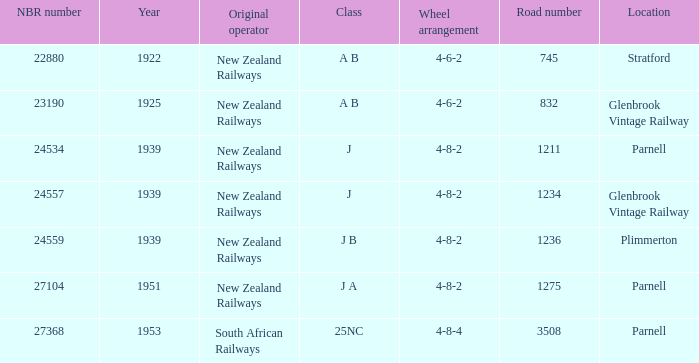What is the count of road numbers that precede 1922? 0.0. 